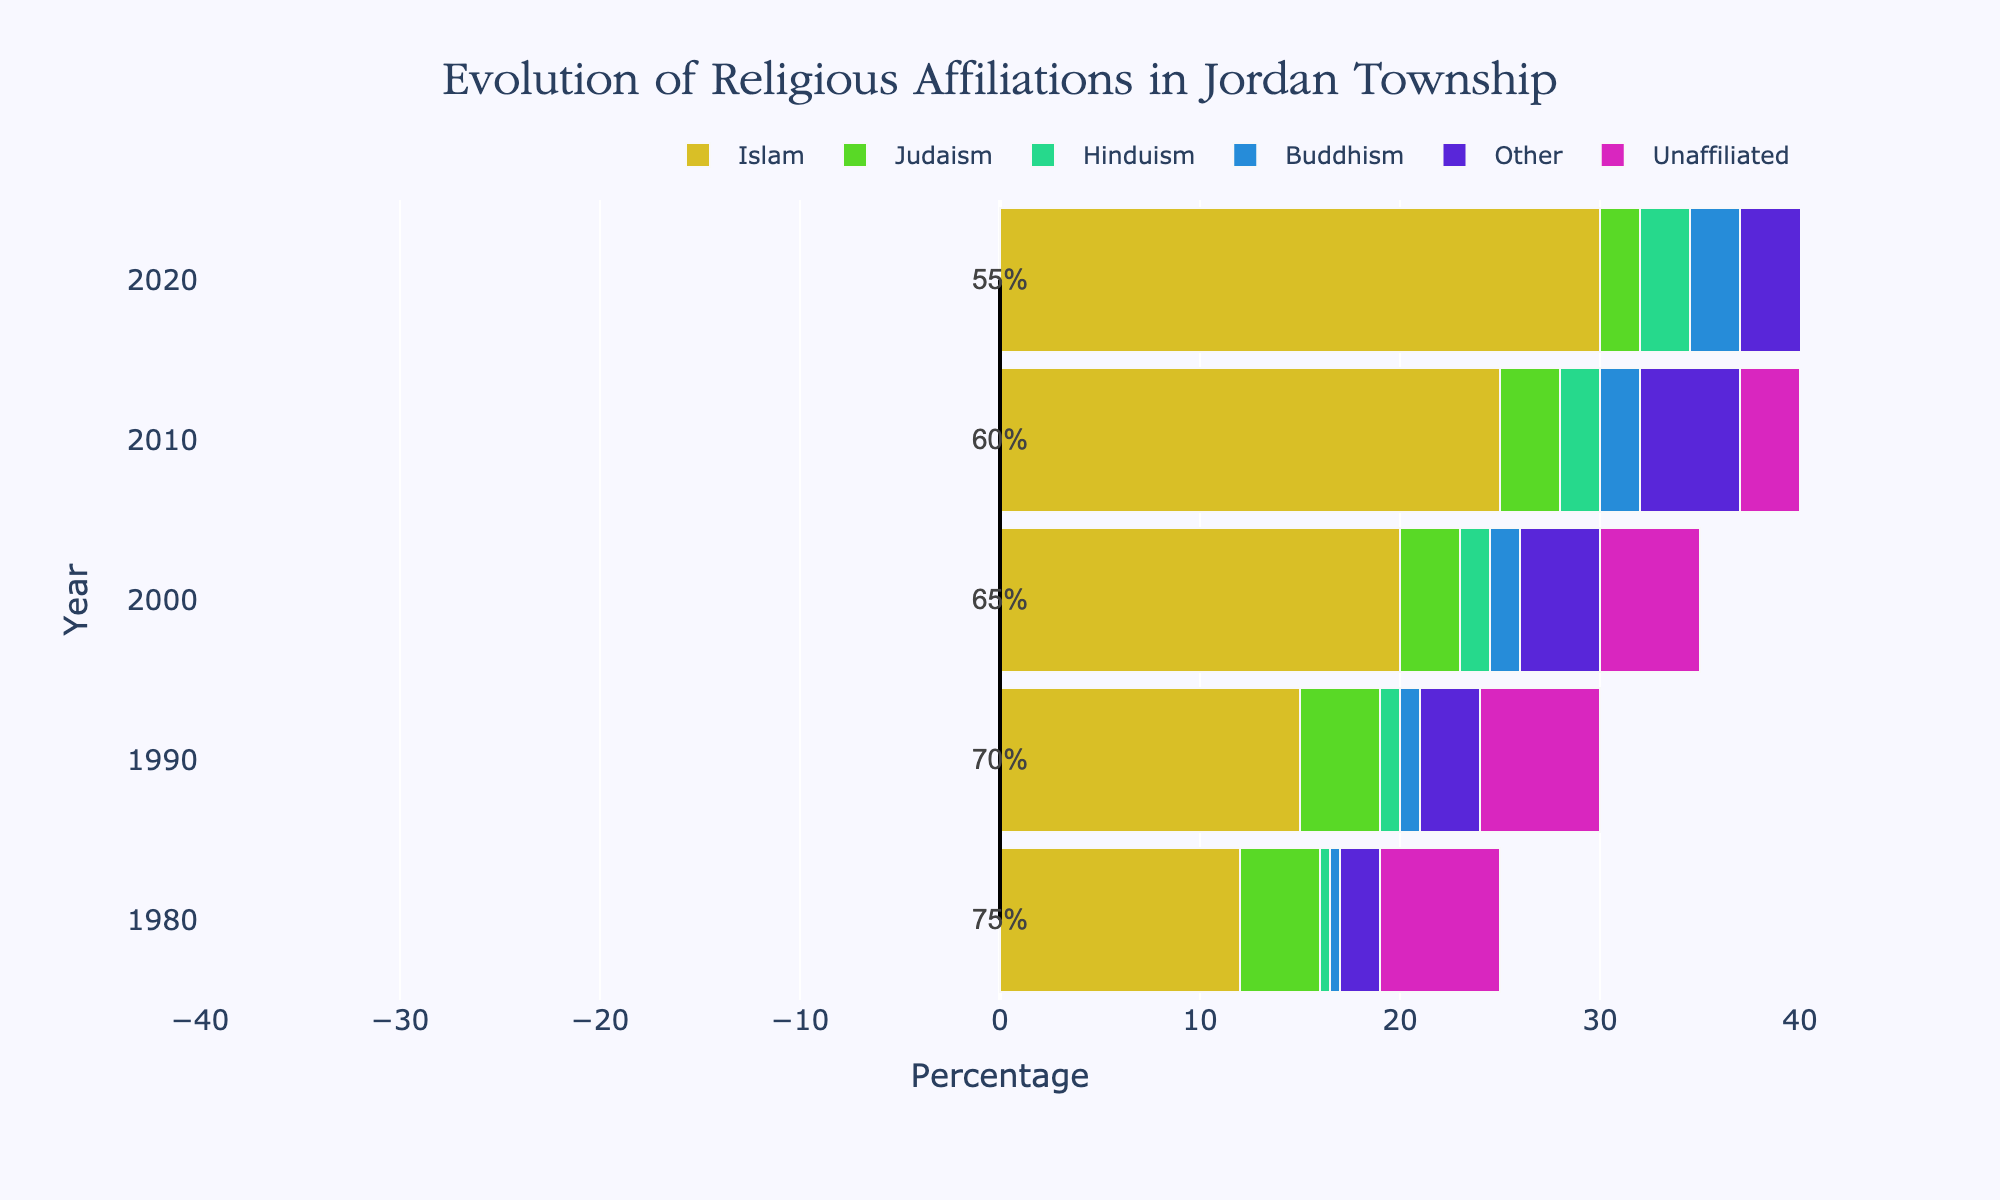Which religion saw the largest increase in percentage from 1980 to 2020? By comparing the percentages for each religion in 1980 and 2020, we see that Islam increased from 12% to 30%, which is the largest increase among all religions.
Answer: Islam How did the percentage of people unaffiliated with any religion change from 1980 to 2020? The percentage of people unaffiliated with any religion decreased from 6% in 1980 to 2% in 2020. This can be observed directly from the data.
Answer: It decreased In which decade did the percentage of Christians decrease the most? By comparing the percentages of Christians over each decade, the largest decrease was from 2000 to 2010 where it went from 65% to 60%, a 5% drop.
Answer: Between 2000 and 2010 What is the sum of percentages of Judaism and Buddhism in 2000? The percentage of Judaism in 2000 is 3% and Buddhism is 1.5%. Adding these gives 3% + 1.5% = 4.5%.
Answer: 4.5% Which religion had the smallest change in percentage from 1980 to 2020? By comparing the percentages for each religion, Judaism had a slight change from 4% to 2%, which is a 2% change, the smallest among all religions.
Answer: Judaism How does the percentage of Hinduism in 2010 compare to Buddhism in the same year? In 2010, the percentage of Hinduism is 2% and Buddhism is also 2%. Therefore, they are equal.
Answer: They are equal What percentage point difference is there between Christianity and Islam in 1980? In 1980, Christianity is at 75% and Islam is at 12%. The difference is 75% - 12% = 63%.
Answer: 63% By how much did the percentage of Others change from 1990 to 2020? The percentage of Others in 1990 is 3% and in 2020 it is 6%. The change is 6% - 3% = 3%.
Answer: 3% What is the average percentage of people unaffiliated with any religion across all decades? The average can be calculated by summing the percentages for all years and dividing by 5: (6% + 6% + 5% + 3% + 2%) / 5 = 4.4%.
Answer: 4.4% Which religion had the highest percentage in 2020? The percentage of Christianity in 2020 is 55%, which is higher than any other religion in that year.
Answer: Christianity 